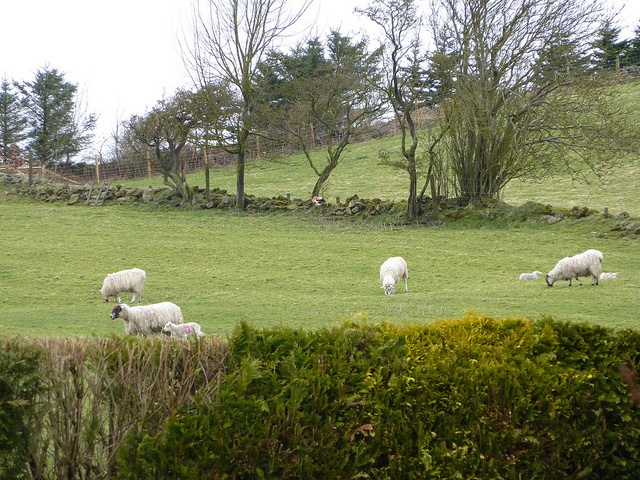Describe the objects in this image and their specific colors. I can see sheep in white, lightgray, darkgray, and gray tones, sheep in white, lightgray, darkgray, and gray tones, sheep in white, lightgray, darkgray, and gray tones, sheep in white, ivory, darkgray, olive, and lightgray tones, and sheep in white, darkgray, lightgray, and olive tones in this image. 